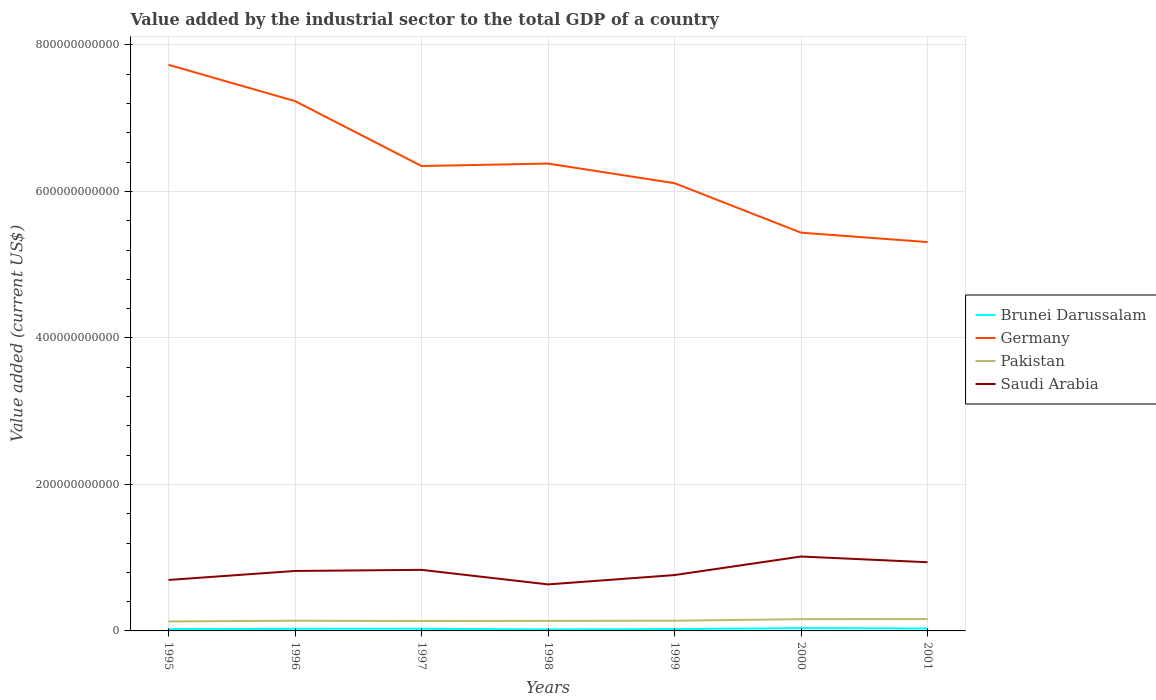How many different coloured lines are there?
Make the answer very short. 4. Does the line corresponding to Saudi Arabia intersect with the line corresponding to Pakistan?
Your response must be concise. No. Across all years, what is the maximum value added by the industrial sector to the total GDP in Saudi Arabia?
Your answer should be compact. 6.35e+1. What is the total value added by the industrial sector to the total GDP in Saudi Arabia in the graph?
Offer a terse response. -2.53e+1. What is the difference between the highest and the second highest value added by the industrial sector to the total GDP in Pakistan?
Provide a succinct answer. 3.25e+09. What is the difference between the highest and the lowest value added by the industrial sector to the total GDP in Brunei Darussalam?
Offer a terse response. 3. How many lines are there?
Offer a very short reply. 4. How many years are there in the graph?
Provide a succinct answer. 7. What is the difference between two consecutive major ticks on the Y-axis?
Provide a succinct answer. 2.00e+11. Are the values on the major ticks of Y-axis written in scientific E-notation?
Your answer should be compact. No. Where does the legend appear in the graph?
Your answer should be very brief. Center right. How many legend labels are there?
Provide a short and direct response. 4. How are the legend labels stacked?
Offer a very short reply. Vertical. What is the title of the graph?
Give a very brief answer. Value added by the industrial sector to the total GDP of a country. Does "Small states" appear as one of the legend labels in the graph?
Provide a succinct answer. No. What is the label or title of the Y-axis?
Make the answer very short. Value added (current US$). What is the Value added (current US$) in Brunei Darussalam in 1995?
Your answer should be very brief. 2.57e+09. What is the Value added (current US$) of Germany in 1995?
Your answer should be compact. 7.73e+11. What is the Value added (current US$) in Pakistan in 1995?
Ensure brevity in your answer.  1.29e+1. What is the Value added (current US$) in Saudi Arabia in 1995?
Your response must be concise. 6.96e+1. What is the Value added (current US$) of Brunei Darussalam in 1996?
Offer a very short reply. 2.88e+09. What is the Value added (current US$) in Germany in 1996?
Provide a short and direct response. 7.23e+11. What is the Value added (current US$) in Pakistan in 1996?
Give a very brief answer. 1.39e+1. What is the Value added (current US$) in Saudi Arabia in 1996?
Keep it short and to the point. 8.18e+1. What is the Value added (current US$) of Brunei Darussalam in 1997?
Your response must be concise. 2.91e+09. What is the Value added (current US$) of Germany in 1997?
Offer a terse response. 6.35e+11. What is the Value added (current US$) in Pakistan in 1997?
Keep it short and to the point. 1.35e+1. What is the Value added (current US$) of Saudi Arabia in 1997?
Your answer should be compact. 8.34e+1. What is the Value added (current US$) in Brunei Darussalam in 1998?
Your answer should be compact. 2.09e+09. What is the Value added (current US$) of Germany in 1998?
Offer a very short reply. 6.38e+11. What is the Value added (current US$) in Pakistan in 1998?
Offer a terse response. 1.37e+1. What is the Value added (current US$) in Saudi Arabia in 1998?
Your answer should be very brief. 6.35e+1. What is the Value added (current US$) of Brunei Darussalam in 1999?
Offer a terse response. 2.54e+09. What is the Value added (current US$) of Germany in 1999?
Keep it short and to the point. 6.11e+11. What is the Value added (current US$) of Pakistan in 1999?
Provide a short and direct response. 1.39e+1. What is the Value added (current US$) in Saudi Arabia in 1999?
Offer a terse response. 7.63e+1. What is the Value added (current US$) in Brunei Darussalam in 2000?
Keep it short and to the point. 3.82e+09. What is the Value added (current US$) in Germany in 2000?
Offer a terse response. 5.44e+11. What is the Value added (current US$) of Pakistan in 2000?
Make the answer very short. 1.61e+1. What is the Value added (current US$) of Saudi Arabia in 2000?
Make the answer very short. 1.02e+11. What is the Value added (current US$) of Brunei Darussalam in 2001?
Offer a terse response. 3.36e+09. What is the Value added (current US$) in Germany in 2001?
Your response must be concise. 5.31e+11. What is the Value added (current US$) in Pakistan in 2001?
Offer a terse response. 1.62e+1. What is the Value added (current US$) in Saudi Arabia in 2001?
Provide a succinct answer. 9.38e+1. Across all years, what is the maximum Value added (current US$) in Brunei Darussalam?
Provide a short and direct response. 3.82e+09. Across all years, what is the maximum Value added (current US$) of Germany?
Ensure brevity in your answer.  7.73e+11. Across all years, what is the maximum Value added (current US$) in Pakistan?
Your answer should be compact. 1.62e+1. Across all years, what is the maximum Value added (current US$) in Saudi Arabia?
Your answer should be very brief. 1.02e+11. Across all years, what is the minimum Value added (current US$) of Brunei Darussalam?
Make the answer very short. 2.09e+09. Across all years, what is the minimum Value added (current US$) in Germany?
Offer a very short reply. 5.31e+11. Across all years, what is the minimum Value added (current US$) of Pakistan?
Provide a short and direct response. 1.29e+1. Across all years, what is the minimum Value added (current US$) of Saudi Arabia?
Keep it short and to the point. 6.35e+1. What is the total Value added (current US$) of Brunei Darussalam in the graph?
Offer a very short reply. 2.02e+1. What is the total Value added (current US$) in Germany in the graph?
Ensure brevity in your answer.  4.45e+12. What is the total Value added (current US$) of Pakistan in the graph?
Offer a very short reply. 1.00e+11. What is the total Value added (current US$) of Saudi Arabia in the graph?
Your response must be concise. 5.70e+11. What is the difference between the Value added (current US$) in Brunei Darussalam in 1995 and that in 1996?
Your answer should be compact. -3.11e+08. What is the difference between the Value added (current US$) in Germany in 1995 and that in 1996?
Your response must be concise. 4.95e+1. What is the difference between the Value added (current US$) of Pakistan in 1995 and that in 1996?
Ensure brevity in your answer.  -9.97e+08. What is the difference between the Value added (current US$) of Saudi Arabia in 1995 and that in 1996?
Provide a succinct answer. -1.22e+1. What is the difference between the Value added (current US$) in Brunei Darussalam in 1995 and that in 1997?
Your answer should be compact. -3.44e+08. What is the difference between the Value added (current US$) of Germany in 1995 and that in 1997?
Ensure brevity in your answer.  1.38e+11. What is the difference between the Value added (current US$) of Pakistan in 1995 and that in 1997?
Keep it short and to the point. -5.29e+08. What is the difference between the Value added (current US$) of Saudi Arabia in 1995 and that in 1997?
Your answer should be very brief. -1.38e+1. What is the difference between the Value added (current US$) in Brunei Darussalam in 1995 and that in 1998?
Make the answer very short. 4.81e+08. What is the difference between the Value added (current US$) in Germany in 1995 and that in 1998?
Your answer should be very brief. 1.35e+11. What is the difference between the Value added (current US$) in Pakistan in 1995 and that in 1998?
Offer a terse response. -7.86e+08. What is the difference between the Value added (current US$) of Saudi Arabia in 1995 and that in 1998?
Your answer should be compact. 6.09e+09. What is the difference between the Value added (current US$) of Brunei Darussalam in 1995 and that in 1999?
Offer a terse response. 3.07e+07. What is the difference between the Value added (current US$) of Germany in 1995 and that in 1999?
Give a very brief answer. 1.62e+11. What is the difference between the Value added (current US$) of Pakistan in 1995 and that in 1999?
Ensure brevity in your answer.  -9.90e+08. What is the difference between the Value added (current US$) in Saudi Arabia in 1995 and that in 1999?
Your answer should be compact. -6.67e+09. What is the difference between the Value added (current US$) of Brunei Darussalam in 1995 and that in 2000?
Offer a very short reply. -1.25e+09. What is the difference between the Value added (current US$) in Germany in 1995 and that in 2000?
Provide a short and direct response. 2.29e+11. What is the difference between the Value added (current US$) of Pakistan in 1995 and that in 2000?
Give a very brief answer. -3.13e+09. What is the difference between the Value added (current US$) in Saudi Arabia in 1995 and that in 2000?
Ensure brevity in your answer.  -3.20e+1. What is the difference between the Value added (current US$) of Brunei Darussalam in 1995 and that in 2001?
Give a very brief answer. -7.94e+08. What is the difference between the Value added (current US$) of Germany in 1995 and that in 2001?
Make the answer very short. 2.42e+11. What is the difference between the Value added (current US$) of Pakistan in 1995 and that in 2001?
Your answer should be compact. -3.25e+09. What is the difference between the Value added (current US$) of Saudi Arabia in 1995 and that in 2001?
Your answer should be compact. -2.42e+1. What is the difference between the Value added (current US$) of Brunei Darussalam in 1996 and that in 1997?
Provide a short and direct response. -3.26e+07. What is the difference between the Value added (current US$) in Germany in 1996 and that in 1997?
Keep it short and to the point. 8.86e+1. What is the difference between the Value added (current US$) of Pakistan in 1996 and that in 1997?
Give a very brief answer. 4.68e+08. What is the difference between the Value added (current US$) in Saudi Arabia in 1996 and that in 1997?
Ensure brevity in your answer.  -1.53e+09. What is the difference between the Value added (current US$) in Brunei Darussalam in 1996 and that in 1998?
Ensure brevity in your answer.  7.93e+08. What is the difference between the Value added (current US$) of Germany in 1996 and that in 1998?
Give a very brief answer. 8.53e+1. What is the difference between the Value added (current US$) of Pakistan in 1996 and that in 1998?
Your answer should be compact. 2.12e+08. What is the difference between the Value added (current US$) of Saudi Arabia in 1996 and that in 1998?
Your answer should be compact. 1.83e+1. What is the difference between the Value added (current US$) in Brunei Darussalam in 1996 and that in 1999?
Provide a short and direct response. 3.42e+08. What is the difference between the Value added (current US$) of Germany in 1996 and that in 1999?
Offer a very short reply. 1.12e+11. What is the difference between the Value added (current US$) in Pakistan in 1996 and that in 1999?
Keep it short and to the point. 7.65e+06. What is the difference between the Value added (current US$) of Saudi Arabia in 1996 and that in 1999?
Make the answer very short. 5.58e+09. What is the difference between the Value added (current US$) in Brunei Darussalam in 1996 and that in 2000?
Your answer should be very brief. -9.41e+08. What is the difference between the Value added (current US$) in Germany in 1996 and that in 2000?
Your response must be concise. 1.80e+11. What is the difference between the Value added (current US$) of Pakistan in 1996 and that in 2000?
Make the answer very short. -2.13e+09. What is the difference between the Value added (current US$) in Saudi Arabia in 1996 and that in 2000?
Provide a short and direct response. -1.97e+1. What is the difference between the Value added (current US$) in Brunei Darussalam in 1996 and that in 2001?
Make the answer very short. -4.83e+08. What is the difference between the Value added (current US$) of Germany in 1996 and that in 2001?
Provide a succinct answer. 1.92e+11. What is the difference between the Value added (current US$) of Pakistan in 1996 and that in 2001?
Keep it short and to the point. -2.26e+09. What is the difference between the Value added (current US$) in Saudi Arabia in 1996 and that in 2001?
Offer a terse response. -1.19e+1. What is the difference between the Value added (current US$) in Brunei Darussalam in 1997 and that in 1998?
Offer a very short reply. 8.25e+08. What is the difference between the Value added (current US$) of Germany in 1997 and that in 1998?
Your answer should be compact. -3.32e+09. What is the difference between the Value added (current US$) in Pakistan in 1997 and that in 1998?
Offer a very short reply. -2.56e+08. What is the difference between the Value added (current US$) of Saudi Arabia in 1997 and that in 1998?
Provide a succinct answer. 1.99e+1. What is the difference between the Value added (current US$) in Brunei Darussalam in 1997 and that in 1999?
Make the answer very short. 3.74e+08. What is the difference between the Value added (current US$) of Germany in 1997 and that in 1999?
Keep it short and to the point. 2.35e+1. What is the difference between the Value added (current US$) of Pakistan in 1997 and that in 1999?
Ensure brevity in your answer.  -4.60e+08. What is the difference between the Value added (current US$) in Saudi Arabia in 1997 and that in 1999?
Your answer should be compact. 7.11e+09. What is the difference between the Value added (current US$) in Brunei Darussalam in 1997 and that in 2000?
Offer a terse response. -9.08e+08. What is the difference between the Value added (current US$) in Germany in 1997 and that in 2000?
Offer a very short reply. 9.10e+1. What is the difference between the Value added (current US$) in Pakistan in 1997 and that in 2000?
Provide a short and direct response. -2.60e+09. What is the difference between the Value added (current US$) in Saudi Arabia in 1997 and that in 2000?
Provide a short and direct response. -1.82e+1. What is the difference between the Value added (current US$) in Brunei Darussalam in 1997 and that in 2001?
Provide a short and direct response. -4.50e+08. What is the difference between the Value added (current US$) of Germany in 1997 and that in 2001?
Offer a terse response. 1.04e+11. What is the difference between the Value added (current US$) in Pakistan in 1997 and that in 2001?
Offer a very short reply. -2.73e+09. What is the difference between the Value added (current US$) of Saudi Arabia in 1997 and that in 2001?
Give a very brief answer. -1.04e+1. What is the difference between the Value added (current US$) in Brunei Darussalam in 1998 and that in 1999?
Your answer should be very brief. -4.51e+08. What is the difference between the Value added (current US$) in Germany in 1998 and that in 1999?
Offer a terse response. 2.68e+1. What is the difference between the Value added (current US$) in Pakistan in 1998 and that in 1999?
Give a very brief answer. -2.04e+08. What is the difference between the Value added (current US$) in Saudi Arabia in 1998 and that in 1999?
Keep it short and to the point. -1.28e+1. What is the difference between the Value added (current US$) in Brunei Darussalam in 1998 and that in 2000?
Keep it short and to the point. -1.73e+09. What is the difference between the Value added (current US$) in Germany in 1998 and that in 2000?
Make the answer very short. 9.43e+1. What is the difference between the Value added (current US$) in Pakistan in 1998 and that in 2000?
Give a very brief answer. -2.34e+09. What is the difference between the Value added (current US$) of Saudi Arabia in 1998 and that in 2000?
Offer a terse response. -3.81e+1. What is the difference between the Value added (current US$) in Brunei Darussalam in 1998 and that in 2001?
Your answer should be compact. -1.28e+09. What is the difference between the Value added (current US$) of Germany in 1998 and that in 2001?
Ensure brevity in your answer.  1.07e+11. What is the difference between the Value added (current US$) in Pakistan in 1998 and that in 2001?
Your answer should be very brief. -2.47e+09. What is the difference between the Value added (current US$) in Saudi Arabia in 1998 and that in 2001?
Ensure brevity in your answer.  -3.02e+1. What is the difference between the Value added (current US$) of Brunei Darussalam in 1999 and that in 2000?
Provide a succinct answer. -1.28e+09. What is the difference between the Value added (current US$) of Germany in 1999 and that in 2000?
Offer a terse response. 6.75e+1. What is the difference between the Value added (current US$) of Pakistan in 1999 and that in 2000?
Keep it short and to the point. -2.14e+09. What is the difference between the Value added (current US$) in Saudi Arabia in 1999 and that in 2000?
Offer a very short reply. -2.53e+1. What is the difference between the Value added (current US$) in Brunei Darussalam in 1999 and that in 2001?
Your answer should be very brief. -8.25e+08. What is the difference between the Value added (current US$) of Germany in 1999 and that in 2001?
Make the answer very short. 8.03e+1. What is the difference between the Value added (current US$) of Pakistan in 1999 and that in 2001?
Your answer should be compact. -2.27e+09. What is the difference between the Value added (current US$) of Saudi Arabia in 1999 and that in 2001?
Your answer should be very brief. -1.75e+1. What is the difference between the Value added (current US$) in Brunei Darussalam in 2000 and that in 2001?
Keep it short and to the point. 4.58e+08. What is the difference between the Value added (current US$) in Germany in 2000 and that in 2001?
Provide a short and direct response. 1.28e+1. What is the difference between the Value added (current US$) in Pakistan in 2000 and that in 2001?
Offer a terse response. -1.25e+08. What is the difference between the Value added (current US$) of Saudi Arabia in 2000 and that in 2001?
Offer a very short reply. 7.83e+09. What is the difference between the Value added (current US$) in Brunei Darussalam in 1995 and the Value added (current US$) in Germany in 1996?
Offer a very short reply. -7.21e+11. What is the difference between the Value added (current US$) of Brunei Darussalam in 1995 and the Value added (current US$) of Pakistan in 1996?
Offer a terse response. -1.14e+1. What is the difference between the Value added (current US$) of Brunei Darussalam in 1995 and the Value added (current US$) of Saudi Arabia in 1996?
Offer a terse response. -7.93e+1. What is the difference between the Value added (current US$) of Germany in 1995 and the Value added (current US$) of Pakistan in 1996?
Your answer should be compact. 7.59e+11. What is the difference between the Value added (current US$) of Germany in 1995 and the Value added (current US$) of Saudi Arabia in 1996?
Give a very brief answer. 6.91e+11. What is the difference between the Value added (current US$) in Pakistan in 1995 and the Value added (current US$) in Saudi Arabia in 1996?
Your answer should be compact. -6.89e+1. What is the difference between the Value added (current US$) in Brunei Darussalam in 1995 and the Value added (current US$) in Germany in 1997?
Ensure brevity in your answer.  -6.32e+11. What is the difference between the Value added (current US$) of Brunei Darussalam in 1995 and the Value added (current US$) of Pakistan in 1997?
Ensure brevity in your answer.  -1.09e+1. What is the difference between the Value added (current US$) in Brunei Darussalam in 1995 and the Value added (current US$) in Saudi Arabia in 1997?
Make the answer very short. -8.08e+1. What is the difference between the Value added (current US$) of Germany in 1995 and the Value added (current US$) of Pakistan in 1997?
Ensure brevity in your answer.  7.59e+11. What is the difference between the Value added (current US$) in Germany in 1995 and the Value added (current US$) in Saudi Arabia in 1997?
Make the answer very short. 6.89e+11. What is the difference between the Value added (current US$) of Pakistan in 1995 and the Value added (current US$) of Saudi Arabia in 1997?
Your answer should be very brief. -7.04e+1. What is the difference between the Value added (current US$) of Brunei Darussalam in 1995 and the Value added (current US$) of Germany in 1998?
Ensure brevity in your answer.  -6.35e+11. What is the difference between the Value added (current US$) of Brunei Darussalam in 1995 and the Value added (current US$) of Pakistan in 1998?
Your answer should be compact. -1.11e+1. What is the difference between the Value added (current US$) in Brunei Darussalam in 1995 and the Value added (current US$) in Saudi Arabia in 1998?
Provide a short and direct response. -6.09e+1. What is the difference between the Value added (current US$) of Germany in 1995 and the Value added (current US$) of Pakistan in 1998?
Offer a very short reply. 7.59e+11. What is the difference between the Value added (current US$) of Germany in 1995 and the Value added (current US$) of Saudi Arabia in 1998?
Provide a short and direct response. 7.09e+11. What is the difference between the Value added (current US$) in Pakistan in 1995 and the Value added (current US$) in Saudi Arabia in 1998?
Offer a very short reply. -5.06e+1. What is the difference between the Value added (current US$) in Brunei Darussalam in 1995 and the Value added (current US$) in Germany in 1999?
Offer a very short reply. -6.09e+11. What is the difference between the Value added (current US$) of Brunei Darussalam in 1995 and the Value added (current US$) of Pakistan in 1999?
Your answer should be very brief. -1.14e+1. What is the difference between the Value added (current US$) of Brunei Darussalam in 1995 and the Value added (current US$) of Saudi Arabia in 1999?
Your answer should be compact. -7.37e+1. What is the difference between the Value added (current US$) of Germany in 1995 and the Value added (current US$) of Pakistan in 1999?
Keep it short and to the point. 7.59e+11. What is the difference between the Value added (current US$) in Germany in 1995 and the Value added (current US$) in Saudi Arabia in 1999?
Give a very brief answer. 6.97e+11. What is the difference between the Value added (current US$) of Pakistan in 1995 and the Value added (current US$) of Saudi Arabia in 1999?
Provide a short and direct response. -6.33e+1. What is the difference between the Value added (current US$) of Brunei Darussalam in 1995 and the Value added (current US$) of Germany in 2000?
Your response must be concise. -5.41e+11. What is the difference between the Value added (current US$) of Brunei Darussalam in 1995 and the Value added (current US$) of Pakistan in 2000?
Ensure brevity in your answer.  -1.35e+1. What is the difference between the Value added (current US$) of Brunei Darussalam in 1995 and the Value added (current US$) of Saudi Arabia in 2000?
Offer a terse response. -9.90e+1. What is the difference between the Value added (current US$) of Germany in 1995 and the Value added (current US$) of Pakistan in 2000?
Offer a terse response. 7.57e+11. What is the difference between the Value added (current US$) of Germany in 1995 and the Value added (current US$) of Saudi Arabia in 2000?
Your answer should be compact. 6.71e+11. What is the difference between the Value added (current US$) in Pakistan in 1995 and the Value added (current US$) in Saudi Arabia in 2000?
Provide a succinct answer. -8.87e+1. What is the difference between the Value added (current US$) in Brunei Darussalam in 1995 and the Value added (current US$) in Germany in 2001?
Your answer should be compact. -5.28e+11. What is the difference between the Value added (current US$) of Brunei Darussalam in 1995 and the Value added (current US$) of Pakistan in 2001?
Ensure brevity in your answer.  -1.36e+1. What is the difference between the Value added (current US$) in Brunei Darussalam in 1995 and the Value added (current US$) in Saudi Arabia in 2001?
Keep it short and to the point. -9.12e+1. What is the difference between the Value added (current US$) of Germany in 1995 and the Value added (current US$) of Pakistan in 2001?
Your response must be concise. 7.57e+11. What is the difference between the Value added (current US$) of Germany in 1995 and the Value added (current US$) of Saudi Arabia in 2001?
Provide a succinct answer. 6.79e+11. What is the difference between the Value added (current US$) in Pakistan in 1995 and the Value added (current US$) in Saudi Arabia in 2001?
Your answer should be compact. -8.08e+1. What is the difference between the Value added (current US$) in Brunei Darussalam in 1996 and the Value added (current US$) in Germany in 1997?
Offer a terse response. -6.32e+11. What is the difference between the Value added (current US$) in Brunei Darussalam in 1996 and the Value added (current US$) in Pakistan in 1997?
Make the answer very short. -1.06e+1. What is the difference between the Value added (current US$) of Brunei Darussalam in 1996 and the Value added (current US$) of Saudi Arabia in 1997?
Offer a terse response. -8.05e+1. What is the difference between the Value added (current US$) of Germany in 1996 and the Value added (current US$) of Pakistan in 1997?
Your response must be concise. 7.10e+11. What is the difference between the Value added (current US$) in Germany in 1996 and the Value added (current US$) in Saudi Arabia in 1997?
Make the answer very short. 6.40e+11. What is the difference between the Value added (current US$) of Pakistan in 1996 and the Value added (current US$) of Saudi Arabia in 1997?
Offer a terse response. -6.94e+1. What is the difference between the Value added (current US$) of Brunei Darussalam in 1996 and the Value added (current US$) of Germany in 1998?
Your answer should be very brief. -6.35e+11. What is the difference between the Value added (current US$) in Brunei Darussalam in 1996 and the Value added (current US$) in Pakistan in 1998?
Make the answer very short. -1.08e+1. What is the difference between the Value added (current US$) in Brunei Darussalam in 1996 and the Value added (current US$) in Saudi Arabia in 1998?
Ensure brevity in your answer.  -6.06e+1. What is the difference between the Value added (current US$) in Germany in 1996 and the Value added (current US$) in Pakistan in 1998?
Provide a short and direct response. 7.10e+11. What is the difference between the Value added (current US$) of Germany in 1996 and the Value added (current US$) of Saudi Arabia in 1998?
Make the answer very short. 6.60e+11. What is the difference between the Value added (current US$) of Pakistan in 1996 and the Value added (current US$) of Saudi Arabia in 1998?
Give a very brief answer. -4.96e+1. What is the difference between the Value added (current US$) in Brunei Darussalam in 1996 and the Value added (current US$) in Germany in 1999?
Keep it short and to the point. -6.08e+11. What is the difference between the Value added (current US$) of Brunei Darussalam in 1996 and the Value added (current US$) of Pakistan in 1999?
Offer a very short reply. -1.10e+1. What is the difference between the Value added (current US$) in Brunei Darussalam in 1996 and the Value added (current US$) in Saudi Arabia in 1999?
Keep it short and to the point. -7.34e+1. What is the difference between the Value added (current US$) of Germany in 1996 and the Value added (current US$) of Pakistan in 1999?
Offer a terse response. 7.09e+11. What is the difference between the Value added (current US$) in Germany in 1996 and the Value added (current US$) in Saudi Arabia in 1999?
Ensure brevity in your answer.  6.47e+11. What is the difference between the Value added (current US$) in Pakistan in 1996 and the Value added (current US$) in Saudi Arabia in 1999?
Provide a short and direct response. -6.23e+1. What is the difference between the Value added (current US$) of Brunei Darussalam in 1996 and the Value added (current US$) of Germany in 2000?
Ensure brevity in your answer.  -5.41e+11. What is the difference between the Value added (current US$) in Brunei Darussalam in 1996 and the Value added (current US$) in Pakistan in 2000?
Give a very brief answer. -1.32e+1. What is the difference between the Value added (current US$) of Brunei Darussalam in 1996 and the Value added (current US$) of Saudi Arabia in 2000?
Give a very brief answer. -9.87e+1. What is the difference between the Value added (current US$) of Germany in 1996 and the Value added (current US$) of Pakistan in 2000?
Make the answer very short. 7.07e+11. What is the difference between the Value added (current US$) in Germany in 1996 and the Value added (current US$) in Saudi Arabia in 2000?
Provide a succinct answer. 6.22e+11. What is the difference between the Value added (current US$) of Pakistan in 1996 and the Value added (current US$) of Saudi Arabia in 2000?
Your answer should be compact. -8.77e+1. What is the difference between the Value added (current US$) in Brunei Darussalam in 1996 and the Value added (current US$) in Germany in 2001?
Offer a terse response. -5.28e+11. What is the difference between the Value added (current US$) of Brunei Darussalam in 1996 and the Value added (current US$) of Pakistan in 2001?
Ensure brevity in your answer.  -1.33e+1. What is the difference between the Value added (current US$) in Brunei Darussalam in 1996 and the Value added (current US$) in Saudi Arabia in 2001?
Your answer should be compact. -9.09e+1. What is the difference between the Value added (current US$) of Germany in 1996 and the Value added (current US$) of Pakistan in 2001?
Your answer should be compact. 7.07e+11. What is the difference between the Value added (current US$) of Germany in 1996 and the Value added (current US$) of Saudi Arabia in 2001?
Give a very brief answer. 6.30e+11. What is the difference between the Value added (current US$) of Pakistan in 1996 and the Value added (current US$) of Saudi Arabia in 2001?
Your response must be concise. -7.98e+1. What is the difference between the Value added (current US$) in Brunei Darussalam in 1997 and the Value added (current US$) in Germany in 1998?
Ensure brevity in your answer.  -6.35e+11. What is the difference between the Value added (current US$) of Brunei Darussalam in 1997 and the Value added (current US$) of Pakistan in 1998?
Make the answer very short. -1.08e+1. What is the difference between the Value added (current US$) of Brunei Darussalam in 1997 and the Value added (current US$) of Saudi Arabia in 1998?
Your answer should be compact. -6.06e+1. What is the difference between the Value added (current US$) in Germany in 1997 and the Value added (current US$) in Pakistan in 1998?
Provide a succinct answer. 6.21e+11. What is the difference between the Value added (current US$) in Germany in 1997 and the Value added (current US$) in Saudi Arabia in 1998?
Ensure brevity in your answer.  5.71e+11. What is the difference between the Value added (current US$) in Pakistan in 1997 and the Value added (current US$) in Saudi Arabia in 1998?
Your answer should be compact. -5.00e+1. What is the difference between the Value added (current US$) of Brunei Darussalam in 1997 and the Value added (current US$) of Germany in 1999?
Offer a very short reply. -6.08e+11. What is the difference between the Value added (current US$) in Brunei Darussalam in 1997 and the Value added (current US$) in Pakistan in 1999?
Ensure brevity in your answer.  -1.10e+1. What is the difference between the Value added (current US$) of Brunei Darussalam in 1997 and the Value added (current US$) of Saudi Arabia in 1999?
Provide a succinct answer. -7.33e+1. What is the difference between the Value added (current US$) in Germany in 1997 and the Value added (current US$) in Pakistan in 1999?
Your response must be concise. 6.21e+11. What is the difference between the Value added (current US$) in Germany in 1997 and the Value added (current US$) in Saudi Arabia in 1999?
Provide a succinct answer. 5.58e+11. What is the difference between the Value added (current US$) of Pakistan in 1997 and the Value added (current US$) of Saudi Arabia in 1999?
Keep it short and to the point. -6.28e+1. What is the difference between the Value added (current US$) of Brunei Darussalam in 1997 and the Value added (current US$) of Germany in 2000?
Your response must be concise. -5.41e+11. What is the difference between the Value added (current US$) of Brunei Darussalam in 1997 and the Value added (current US$) of Pakistan in 2000?
Provide a succinct answer. -1.31e+1. What is the difference between the Value added (current US$) in Brunei Darussalam in 1997 and the Value added (current US$) in Saudi Arabia in 2000?
Ensure brevity in your answer.  -9.87e+1. What is the difference between the Value added (current US$) in Germany in 1997 and the Value added (current US$) in Pakistan in 2000?
Make the answer very short. 6.19e+11. What is the difference between the Value added (current US$) in Germany in 1997 and the Value added (current US$) in Saudi Arabia in 2000?
Offer a very short reply. 5.33e+11. What is the difference between the Value added (current US$) of Pakistan in 1997 and the Value added (current US$) of Saudi Arabia in 2000?
Keep it short and to the point. -8.81e+1. What is the difference between the Value added (current US$) in Brunei Darussalam in 1997 and the Value added (current US$) in Germany in 2001?
Your response must be concise. -5.28e+11. What is the difference between the Value added (current US$) in Brunei Darussalam in 1997 and the Value added (current US$) in Pakistan in 2001?
Provide a succinct answer. -1.33e+1. What is the difference between the Value added (current US$) in Brunei Darussalam in 1997 and the Value added (current US$) in Saudi Arabia in 2001?
Ensure brevity in your answer.  -9.08e+1. What is the difference between the Value added (current US$) in Germany in 1997 and the Value added (current US$) in Pakistan in 2001?
Keep it short and to the point. 6.18e+11. What is the difference between the Value added (current US$) in Germany in 1997 and the Value added (current US$) in Saudi Arabia in 2001?
Offer a very short reply. 5.41e+11. What is the difference between the Value added (current US$) in Pakistan in 1997 and the Value added (current US$) in Saudi Arabia in 2001?
Your response must be concise. -8.03e+1. What is the difference between the Value added (current US$) of Brunei Darussalam in 1998 and the Value added (current US$) of Germany in 1999?
Make the answer very short. -6.09e+11. What is the difference between the Value added (current US$) in Brunei Darussalam in 1998 and the Value added (current US$) in Pakistan in 1999?
Keep it short and to the point. -1.18e+1. What is the difference between the Value added (current US$) of Brunei Darussalam in 1998 and the Value added (current US$) of Saudi Arabia in 1999?
Your answer should be compact. -7.42e+1. What is the difference between the Value added (current US$) in Germany in 1998 and the Value added (current US$) in Pakistan in 1999?
Make the answer very short. 6.24e+11. What is the difference between the Value added (current US$) in Germany in 1998 and the Value added (current US$) in Saudi Arabia in 1999?
Provide a short and direct response. 5.62e+11. What is the difference between the Value added (current US$) of Pakistan in 1998 and the Value added (current US$) of Saudi Arabia in 1999?
Your answer should be very brief. -6.25e+1. What is the difference between the Value added (current US$) of Brunei Darussalam in 1998 and the Value added (current US$) of Germany in 2000?
Ensure brevity in your answer.  -5.42e+11. What is the difference between the Value added (current US$) in Brunei Darussalam in 1998 and the Value added (current US$) in Pakistan in 2000?
Make the answer very short. -1.40e+1. What is the difference between the Value added (current US$) in Brunei Darussalam in 1998 and the Value added (current US$) in Saudi Arabia in 2000?
Your response must be concise. -9.95e+1. What is the difference between the Value added (current US$) in Germany in 1998 and the Value added (current US$) in Pakistan in 2000?
Provide a short and direct response. 6.22e+11. What is the difference between the Value added (current US$) of Germany in 1998 and the Value added (current US$) of Saudi Arabia in 2000?
Offer a very short reply. 5.36e+11. What is the difference between the Value added (current US$) of Pakistan in 1998 and the Value added (current US$) of Saudi Arabia in 2000?
Provide a succinct answer. -8.79e+1. What is the difference between the Value added (current US$) in Brunei Darussalam in 1998 and the Value added (current US$) in Germany in 2001?
Ensure brevity in your answer.  -5.29e+11. What is the difference between the Value added (current US$) in Brunei Darussalam in 1998 and the Value added (current US$) in Pakistan in 2001?
Give a very brief answer. -1.41e+1. What is the difference between the Value added (current US$) of Brunei Darussalam in 1998 and the Value added (current US$) of Saudi Arabia in 2001?
Give a very brief answer. -9.17e+1. What is the difference between the Value added (current US$) of Germany in 1998 and the Value added (current US$) of Pakistan in 2001?
Provide a succinct answer. 6.22e+11. What is the difference between the Value added (current US$) of Germany in 1998 and the Value added (current US$) of Saudi Arabia in 2001?
Your response must be concise. 5.44e+11. What is the difference between the Value added (current US$) of Pakistan in 1998 and the Value added (current US$) of Saudi Arabia in 2001?
Keep it short and to the point. -8.00e+1. What is the difference between the Value added (current US$) in Brunei Darussalam in 1999 and the Value added (current US$) in Germany in 2000?
Offer a terse response. -5.41e+11. What is the difference between the Value added (current US$) in Brunei Darussalam in 1999 and the Value added (current US$) in Pakistan in 2000?
Your answer should be very brief. -1.35e+1. What is the difference between the Value added (current US$) of Brunei Darussalam in 1999 and the Value added (current US$) of Saudi Arabia in 2000?
Ensure brevity in your answer.  -9.90e+1. What is the difference between the Value added (current US$) in Germany in 1999 and the Value added (current US$) in Pakistan in 2000?
Make the answer very short. 5.95e+11. What is the difference between the Value added (current US$) of Germany in 1999 and the Value added (current US$) of Saudi Arabia in 2000?
Offer a very short reply. 5.10e+11. What is the difference between the Value added (current US$) of Pakistan in 1999 and the Value added (current US$) of Saudi Arabia in 2000?
Your answer should be very brief. -8.77e+1. What is the difference between the Value added (current US$) of Brunei Darussalam in 1999 and the Value added (current US$) of Germany in 2001?
Your answer should be very brief. -5.28e+11. What is the difference between the Value added (current US$) of Brunei Darussalam in 1999 and the Value added (current US$) of Pakistan in 2001?
Offer a very short reply. -1.36e+1. What is the difference between the Value added (current US$) of Brunei Darussalam in 1999 and the Value added (current US$) of Saudi Arabia in 2001?
Provide a succinct answer. -9.12e+1. What is the difference between the Value added (current US$) of Germany in 1999 and the Value added (current US$) of Pakistan in 2001?
Your answer should be compact. 5.95e+11. What is the difference between the Value added (current US$) in Germany in 1999 and the Value added (current US$) in Saudi Arabia in 2001?
Keep it short and to the point. 5.17e+11. What is the difference between the Value added (current US$) in Pakistan in 1999 and the Value added (current US$) in Saudi Arabia in 2001?
Offer a very short reply. -7.98e+1. What is the difference between the Value added (current US$) of Brunei Darussalam in 2000 and the Value added (current US$) of Germany in 2001?
Ensure brevity in your answer.  -5.27e+11. What is the difference between the Value added (current US$) in Brunei Darussalam in 2000 and the Value added (current US$) in Pakistan in 2001?
Offer a terse response. -1.24e+1. What is the difference between the Value added (current US$) in Brunei Darussalam in 2000 and the Value added (current US$) in Saudi Arabia in 2001?
Make the answer very short. -8.99e+1. What is the difference between the Value added (current US$) of Germany in 2000 and the Value added (current US$) of Pakistan in 2001?
Make the answer very short. 5.27e+11. What is the difference between the Value added (current US$) of Germany in 2000 and the Value added (current US$) of Saudi Arabia in 2001?
Provide a succinct answer. 4.50e+11. What is the difference between the Value added (current US$) in Pakistan in 2000 and the Value added (current US$) in Saudi Arabia in 2001?
Your response must be concise. -7.77e+1. What is the average Value added (current US$) of Brunei Darussalam per year?
Your answer should be very brief. 2.88e+09. What is the average Value added (current US$) of Germany per year?
Your response must be concise. 6.36e+11. What is the average Value added (current US$) of Pakistan per year?
Provide a short and direct response. 1.43e+1. What is the average Value added (current US$) in Saudi Arabia per year?
Offer a terse response. 8.14e+1. In the year 1995, what is the difference between the Value added (current US$) of Brunei Darussalam and Value added (current US$) of Germany?
Provide a succinct answer. -7.70e+11. In the year 1995, what is the difference between the Value added (current US$) of Brunei Darussalam and Value added (current US$) of Pakistan?
Ensure brevity in your answer.  -1.04e+1. In the year 1995, what is the difference between the Value added (current US$) of Brunei Darussalam and Value added (current US$) of Saudi Arabia?
Provide a short and direct response. -6.70e+1. In the year 1995, what is the difference between the Value added (current US$) of Germany and Value added (current US$) of Pakistan?
Provide a short and direct response. 7.60e+11. In the year 1995, what is the difference between the Value added (current US$) in Germany and Value added (current US$) in Saudi Arabia?
Provide a succinct answer. 7.03e+11. In the year 1995, what is the difference between the Value added (current US$) of Pakistan and Value added (current US$) of Saudi Arabia?
Provide a succinct answer. -5.67e+1. In the year 1996, what is the difference between the Value added (current US$) in Brunei Darussalam and Value added (current US$) in Germany?
Offer a terse response. -7.20e+11. In the year 1996, what is the difference between the Value added (current US$) in Brunei Darussalam and Value added (current US$) in Pakistan?
Your response must be concise. -1.10e+1. In the year 1996, what is the difference between the Value added (current US$) in Brunei Darussalam and Value added (current US$) in Saudi Arabia?
Ensure brevity in your answer.  -7.90e+1. In the year 1996, what is the difference between the Value added (current US$) of Germany and Value added (current US$) of Pakistan?
Your response must be concise. 7.09e+11. In the year 1996, what is the difference between the Value added (current US$) in Germany and Value added (current US$) in Saudi Arabia?
Give a very brief answer. 6.41e+11. In the year 1996, what is the difference between the Value added (current US$) in Pakistan and Value added (current US$) in Saudi Arabia?
Provide a succinct answer. -6.79e+1. In the year 1997, what is the difference between the Value added (current US$) in Brunei Darussalam and Value added (current US$) in Germany?
Give a very brief answer. -6.32e+11. In the year 1997, what is the difference between the Value added (current US$) of Brunei Darussalam and Value added (current US$) of Pakistan?
Make the answer very short. -1.05e+1. In the year 1997, what is the difference between the Value added (current US$) of Brunei Darussalam and Value added (current US$) of Saudi Arabia?
Provide a succinct answer. -8.05e+1. In the year 1997, what is the difference between the Value added (current US$) of Germany and Value added (current US$) of Pakistan?
Make the answer very short. 6.21e+11. In the year 1997, what is the difference between the Value added (current US$) of Germany and Value added (current US$) of Saudi Arabia?
Ensure brevity in your answer.  5.51e+11. In the year 1997, what is the difference between the Value added (current US$) of Pakistan and Value added (current US$) of Saudi Arabia?
Offer a very short reply. -6.99e+1. In the year 1998, what is the difference between the Value added (current US$) of Brunei Darussalam and Value added (current US$) of Germany?
Your response must be concise. -6.36e+11. In the year 1998, what is the difference between the Value added (current US$) in Brunei Darussalam and Value added (current US$) in Pakistan?
Keep it short and to the point. -1.16e+1. In the year 1998, what is the difference between the Value added (current US$) in Brunei Darussalam and Value added (current US$) in Saudi Arabia?
Offer a terse response. -6.14e+1. In the year 1998, what is the difference between the Value added (current US$) of Germany and Value added (current US$) of Pakistan?
Offer a terse response. 6.24e+11. In the year 1998, what is the difference between the Value added (current US$) in Germany and Value added (current US$) in Saudi Arabia?
Your response must be concise. 5.74e+11. In the year 1998, what is the difference between the Value added (current US$) in Pakistan and Value added (current US$) in Saudi Arabia?
Provide a succinct answer. -4.98e+1. In the year 1999, what is the difference between the Value added (current US$) in Brunei Darussalam and Value added (current US$) in Germany?
Provide a succinct answer. -6.09e+11. In the year 1999, what is the difference between the Value added (current US$) of Brunei Darussalam and Value added (current US$) of Pakistan?
Provide a succinct answer. -1.14e+1. In the year 1999, what is the difference between the Value added (current US$) in Brunei Darussalam and Value added (current US$) in Saudi Arabia?
Ensure brevity in your answer.  -7.37e+1. In the year 1999, what is the difference between the Value added (current US$) in Germany and Value added (current US$) in Pakistan?
Make the answer very short. 5.97e+11. In the year 1999, what is the difference between the Value added (current US$) of Germany and Value added (current US$) of Saudi Arabia?
Keep it short and to the point. 5.35e+11. In the year 1999, what is the difference between the Value added (current US$) in Pakistan and Value added (current US$) in Saudi Arabia?
Your response must be concise. -6.23e+1. In the year 2000, what is the difference between the Value added (current US$) in Brunei Darussalam and Value added (current US$) in Germany?
Keep it short and to the point. -5.40e+11. In the year 2000, what is the difference between the Value added (current US$) of Brunei Darussalam and Value added (current US$) of Pakistan?
Offer a very short reply. -1.22e+1. In the year 2000, what is the difference between the Value added (current US$) of Brunei Darussalam and Value added (current US$) of Saudi Arabia?
Offer a terse response. -9.78e+1. In the year 2000, what is the difference between the Value added (current US$) in Germany and Value added (current US$) in Pakistan?
Provide a short and direct response. 5.28e+11. In the year 2000, what is the difference between the Value added (current US$) in Germany and Value added (current US$) in Saudi Arabia?
Ensure brevity in your answer.  4.42e+11. In the year 2000, what is the difference between the Value added (current US$) in Pakistan and Value added (current US$) in Saudi Arabia?
Provide a short and direct response. -8.55e+1. In the year 2001, what is the difference between the Value added (current US$) of Brunei Darussalam and Value added (current US$) of Germany?
Your answer should be very brief. -5.27e+11. In the year 2001, what is the difference between the Value added (current US$) of Brunei Darussalam and Value added (current US$) of Pakistan?
Offer a very short reply. -1.28e+1. In the year 2001, what is the difference between the Value added (current US$) of Brunei Darussalam and Value added (current US$) of Saudi Arabia?
Your answer should be compact. -9.04e+1. In the year 2001, what is the difference between the Value added (current US$) in Germany and Value added (current US$) in Pakistan?
Make the answer very short. 5.15e+11. In the year 2001, what is the difference between the Value added (current US$) of Germany and Value added (current US$) of Saudi Arabia?
Your answer should be very brief. 4.37e+11. In the year 2001, what is the difference between the Value added (current US$) in Pakistan and Value added (current US$) in Saudi Arabia?
Provide a short and direct response. -7.76e+1. What is the ratio of the Value added (current US$) in Brunei Darussalam in 1995 to that in 1996?
Give a very brief answer. 0.89. What is the ratio of the Value added (current US$) of Germany in 1995 to that in 1996?
Offer a terse response. 1.07. What is the ratio of the Value added (current US$) of Pakistan in 1995 to that in 1996?
Make the answer very short. 0.93. What is the ratio of the Value added (current US$) of Saudi Arabia in 1995 to that in 1996?
Provide a short and direct response. 0.85. What is the ratio of the Value added (current US$) of Brunei Darussalam in 1995 to that in 1997?
Provide a succinct answer. 0.88. What is the ratio of the Value added (current US$) of Germany in 1995 to that in 1997?
Your response must be concise. 1.22. What is the ratio of the Value added (current US$) in Pakistan in 1995 to that in 1997?
Your response must be concise. 0.96. What is the ratio of the Value added (current US$) in Saudi Arabia in 1995 to that in 1997?
Offer a very short reply. 0.83. What is the ratio of the Value added (current US$) in Brunei Darussalam in 1995 to that in 1998?
Keep it short and to the point. 1.23. What is the ratio of the Value added (current US$) in Germany in 1995 to that in 1998?
Your response must be concise. 1.21. What is the ratio of the Value added (current US$) in Pakistan in 1995 to that in 1998?
Offer a very short reply. 0.94. What is the ratio of the Value added (current US$) of Saudi Arabia in 1995 to that in 1998?
Keep it short and to the point. 1.1. What is the ratio of the Value added (current US$) of Brunei Darussalam in 1995 to that in 1999?
Your answer should be compact. 1.01. What is the ratio of the Value added (current US$) of Germany in 1995 to that in 1999?
Keep it short and to the point. 1.26. What is the ratio of the Value added (current US$) in Pakistan in 1995 to that in 1999?
Your response must be concise. 0.93. What is the ratio of the Value added (current US$) in Saudi Arabia in 1995 to that in 1999?
Your response must be concise. 0.91. What is the ratio of the Value added (current US$) of Brunei Darussalam in 1995 to that in 2000?
Your response must be concise. 0.67. What is the ratio of the Value added (current US$) in Germany in 1995 to that in 2000?
Your answer should be very brief. 1.42. What is the ratio of the Value added (current US$) in Pakistan in 1995 to that in 2000?
Make the answer very short. 0.81. What is the ratio of the Value added (current US$) of Saudi Arabia in 1995 to that in 2000?
Your response must be concise. 0.69. What is the ratio of the Value added (current US$) in Brunei Darussalam in 1995 to that in 2001?
Give a very brief answer. 0.76. What is the ratio of the Value added (current US$) of Germany in 1995 to that in 2001?
Offer a very short reply. 1.46. What is the ratio of the Value added (current US$) in Pakistan in 1995 to that in 2001?
Give a very brief answer. 0.8. What is the ratio of the Value added (current US$) of Saudi Arabia in 1995 to that in 2001?
Provide a short and direct response. 0.74. What is the ratio of the Value added (current US$) of Germany in 1996 to that in 1997?
Your response must be concise. 1.14. What is the ratio of the Value added (current US$) of Pakistan in 1996 to that in 1997?
Your response must be concise. 1.03. What is the ratio of the Value added (current US$) of Saudi Arabia in 1996 to that in 1997?
Offer a very short reply. 0.98. What is the ratio of the Value added (current US$) in Brunei Darussalam in 1996 to that in 1998?
Ensure brevity in your answer.  1.38. What is the ratio of the Value added (current US$) in Germany in 1996 to that in 1998?
Offer a very short reply. 1.13. What is the ratio of the Value added (current US$) in Pakistan in 1996 to that in 1998?
Provide a short and direct response. 1.02. What is the ratio of the Value added (current US$) in Saudi Arabia in 1996 to that in 1998?
Make the answer very short. 1.29. What is the ratio of the Value added (current US$) in Brunei Darussalam in 1996 to that in 1999?
Give a very brief answer. 1.13. What is the ratio of the Value added (current US$) of Germany in 1996 to that in 1999?
Provide a succinct answer. 1.18. What is the ratio of the Value added (current US$) in Pakistan in 1996 to that in 1999?
Ensure brevity in your answer.  1. What is the ratio of the Value added (current US$) of Saudi Arabia in 1996 to that in 1999?
Offer a terse response. 1.07. What is the ratio of the Value added (current US$) of Brunei Darussalam in 1996 to that in 2000?
Offer a terse response. 0.75. What is the ratio of the Value added (current US$) of Germany in 1996 to that in 2000?
Your answer should be compact. 1.33. What is the ratio of the Value added (current US$) of Pakistan in 1996 to that in 2000?
Provide a short and direct response. 0.87. What is the ratio of the Value added (current US$) of Saudi Arabia in 1996 to that in 2000?
Offer a terse response. 0.81. What is the ratio of the Value added (current US$) of Brunei Darussalam in 1996 to that in 2001?
Offer a terse response. 0.86. What is the ratio of the Value added (current US$) in Germany in 1996 to that in 2001?
Keep it short and to the point. 1.36. What is the ratio of the Value added (current US$) in Pakistan in 1996 to that in 2001?
Make the answer very short. 0.86. What is the ratio of the Value added (current US$) in Saudi Arabia in 1996 to that in 2001?
Offer a terse response. 0.87. What is the ratio of the Value added (current US$) in Brunei Darussalam in 1997 to that in 1998?
Keep it short and to the point. 1.4. What is the ratio of the Value added (current US$) in Pakistan in 1997 to that in 1998?
Your answer should be very brief. 0.98. What is the ratio of the Value added (current US$) in Saudi Arabia in 1997 to that in 1998?
Offer a terse response. 1.31. What is the ratio of the Value added (current US$) of Brunei Darussalam in 1997 to that in 1999?
Your response must be concise. 1.15. What is the ratio of the Value added (current US$) in Germany in 1997 to that in 1999?
Offer a very short reply. 1.04. What is the ratio of the Value added (current US$) of Pakistan in 1997 to that in 1999?
Your answer should be compact. 0.97. What is the ratio of the Value added (current US$) in Saudi Arabia in 1997 to that in 1999?
Your answer should be very brief. 1.09. What is the ratio of the Value added (current US$) of Brunei Darussalam in 1997 to that in 2000?
Offer a terse response. 0.76. What is the ratio of the Value added (current US$) of Germany in 1997 to that in 2000?
Your answer should be very brief. 1.17. What is the ratio of the Value added (current US$) of Pakistan in 1997 to that in 2000?
Provide a succinct answer. 0.84. What is the ratio of the Value added (current US$) in Saudi Arabia in 1997 to that in 2000?
Your answer should be compact. 0.82. What is the ratio of the Value added (current US$) in Brunei Darussalam in 1997 to that in 2001?
Keep it short and to the point. 0.87. What is the ratio of the Value added (current US$) of Germany in 1997 to that in 2001?
Your answer should be very brief. 1.2. What is the ratio of the Value added (current US$) in Pakistan in 1997 to that in 2001?
Ensure brevity in your answer.  0.83. What is the ratio of the Value added (current US$) in Saudi Arabia in 1997 to that in 2001?
Keep it short and to the point. 0.89. What is the ratio of the Value added (current US$) in Brunei Darussalam in 1998 to that in 1999?
Provide a succinct answer. 0.82. What is the ratio of the Value added (current US$) in Germany in 1998 to that in 1999?
Your response must be concise. 1.04. What is the ratio of the Value added (current US$) in Pakistan in 1998 to that in 1999?
Keep it short and to the point. 0.99. What is the ratio of the Value added (current US$) of Saudi Arabia in 1998 to that in 1999?
Keep it short and to the point. 0.83. What is the ratio of the Value added (current US$) of Brunei Darussalam in 1998 to that in 2000?
Make the answer very short. 0.55. What is the ratio of the Value added (current US$) of Germany in 1998 to that in 2000?
Make the answer very short. 1.17. What is the ratio of the Value added (current US$) in Pakistan in 1998 to that in 2000?
Make the answer very short. 0.85. What is the ratio of the Value added (current US$) in Saudi Arabia in 1998 to that in 2000?
Provide a succinct answer. 0.63. What is the ratio of the Value added (current US$) in Brunei Darussalam in 1998 to that in 2001?
Ensure brevity in your answer.  0.62. What is the ratio of the Value added (current US$) of Germany in 1998 to that in 2001?
Ensure brevity in your answer.  1.2. What is the ratio of the Value added (current US$) of Pakistan in 1998 to that in 2001?
Provide a succinct answer. 0.85. What is the ratio of the Value added (current US$) of Saudi Arabia in 1998 to that in 2001?
Your response must be concise. 0.68. What is the ratio of the Value added (current US$) in Brunei Darussalam in 1999 to that in 2000?
Ensure brevity in your answer.  0.66. What is the ratio of the Value added (current US$) in Germany in 1999 to that in 2000?
Keep it short and to the point. 1.12. What is the ratio of the Value added (current US$) of Pakistan in 1999 to that in 2000?
Your answer should be very brief. 0.87. What is the ratio of the Value added (current US$) in Saudi Arabia in 1999 to that in 2000?
Provide a succinct answer. 0.75. What is the ratio of the Value added (current US$) of Brunei Darussalam in 1999 to that in 2001?
Offer a very short reply. 0.75. What is the ratio of the Value added (current US$) in Germany in 1999 to that in 2001?
Offer a terse response. 1.15. What is the ratio of the Value added (current US$) in Pakistan in 1999 to that in 2001?
Provide a short and direct response. 0.86. What is the ratio of the Value added (current US$) of Saudi Arabia in 1999 to that in 2001?
Provide a short and direct response. 0.81. What is the ratio of the Value added (current US$) in Brunei Darussalam in 2000 to that in 2001?
Your answer should be very brief. 1.14. What is the ratio of the Value added (current US$) of Germany in 2000 to that in 2001?
Make the answer very short. 1.02. What is the ratio of the Value added (current US$) in Saudi Arabia in 2000 to that in 2001?
Offer a very short reply. 1.08. What is the difference between the highest and the second highest Value added (current US$) of Brunei Darussalam?
Your answer should be compact. 4.58e+08. What is the difference between the highest and the second highest Value added (current US$) of Germany?
Ensure brevity in your answer.  4.95e+1. What is the difference between the highest and the second highest Value added (current US$) in Pakistan?
Offer a very short reply. 1.25e+08. What is the difference between the highest and the second highest Value added (current US$) in Saudi Arabia?
Your answer should be compact. 7.83e+09. What is the difference between the highest and the lowest Value added (current US$) of Brunei Darussalam?
Offer a very short reply. 1.73e+09. What is the difference between the highest and the lowest Value added (current US$) in Germany?
Your answer should be very brief. 2.42e+11. What is the difference between the highest and the lowest Value added (current US$) of Pakistan?
Give a very brief answer. 3.25e+09. What is the difference between the highest and the lowest Value added (current US$) in Saudi Arabia?
Provide a short and direct response. 3.81e+1. 